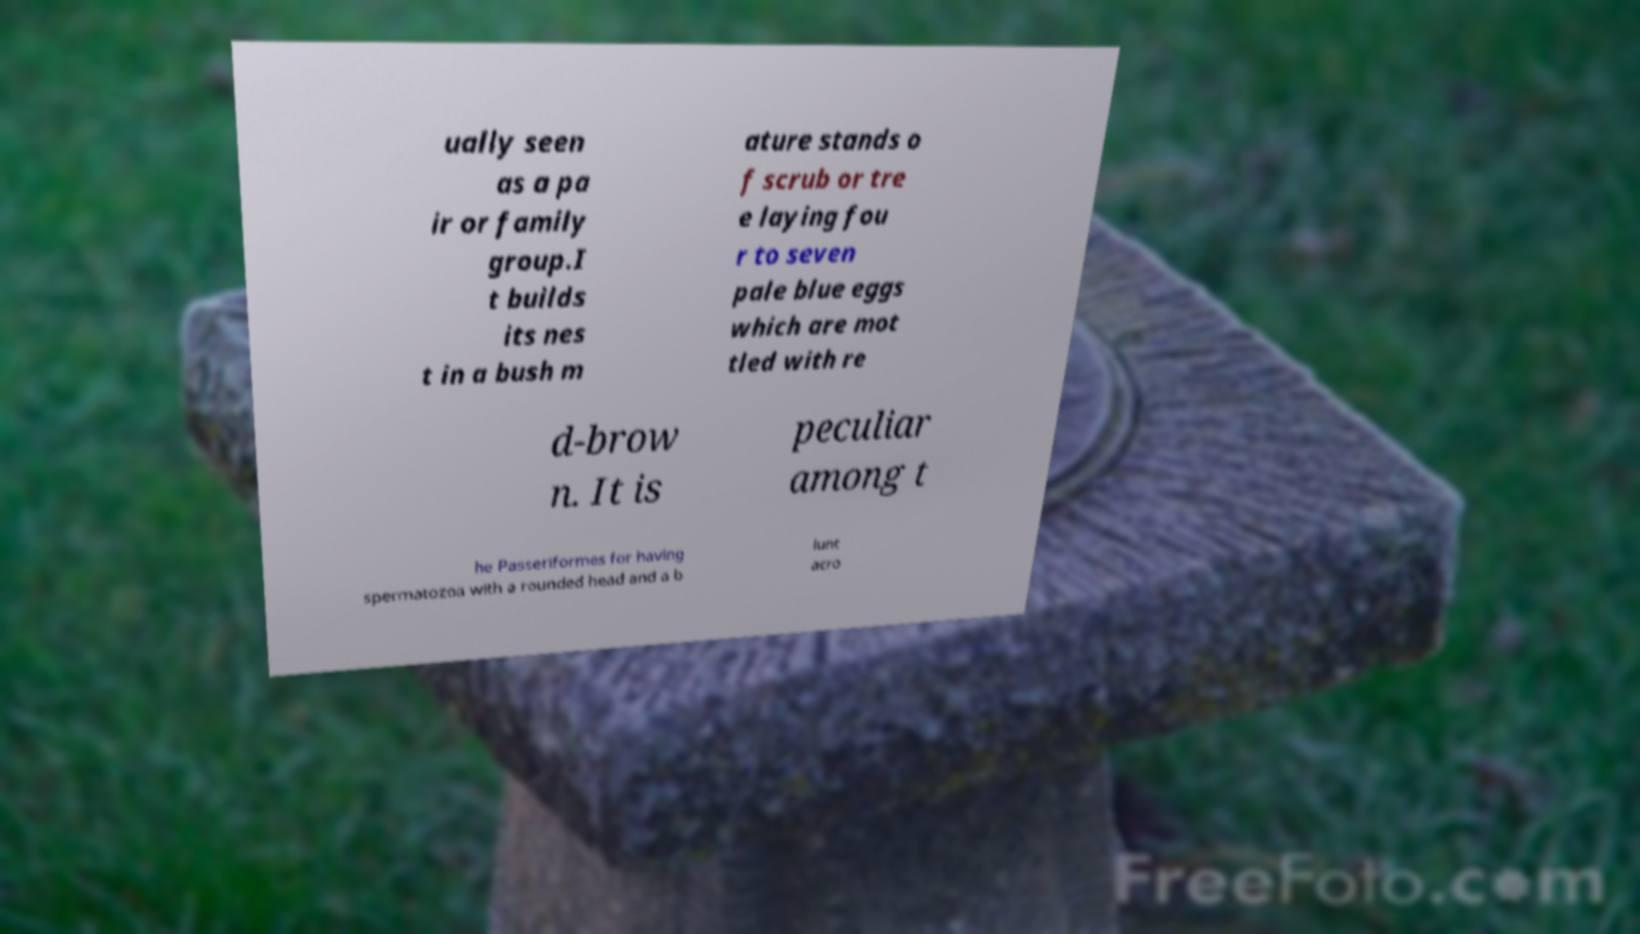I need the written content from this picture converted into text. Can you do that? ually seen as a pa ir or family group.I t builds its nes t in a bush m ature stands o f scrub or tre e laying fou r to seven pale blue eggs which are mot tled with re d-brow n. It is peculiar among t he Passeriformes for having spermatozoa with a rounded head and a b lunt acro 